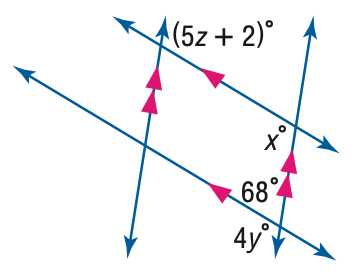Answer the mathemtical geometry problem and directly provide the correct option letter.
Question: Find x in the figure.
Choices: A: 68 B: 102 C: 112 D: 122 C 